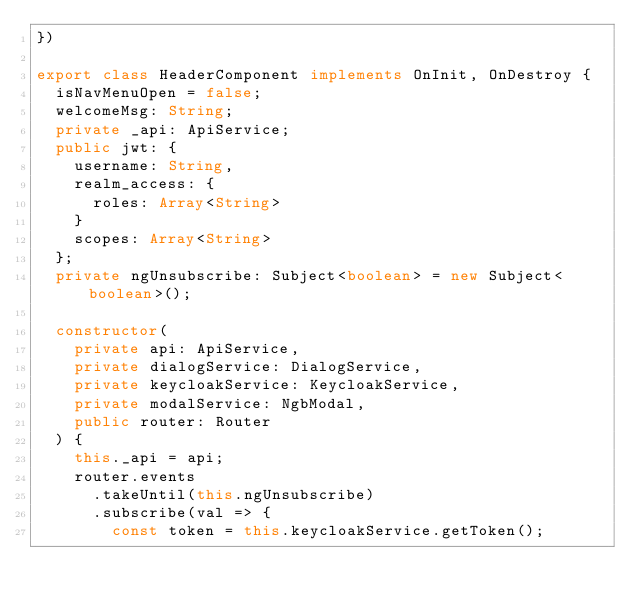<code> <loc_0><loc_0><loc_500><loc_500><_TypeScript_>})

export class HeaderComponent implements OnInit, OnDestroy {
  isNavMenuOpen = false;
  welcomeMsg: String;
  private _api: ApiService;
  public jwt: {
    username: String,
    realm_access: {
      roles: Array<String>
    }
    scopes: Array<String>
  };
  private ngUnsubscribe: Subject<boolean> = new Subject<boolean>();

  constructor(
    private api: ApiService,
    private dialogService: DialogService,
    private keycloakService: KeycloakService,
    private modalService: NgbModal,
    public router: Router
  ) {
    this._api = api;
    router.events
      .takeUntil(this.ngUnsubscribe)
      .subscribe(val => {
        const token = this.keycloakService.getToken();</code> 